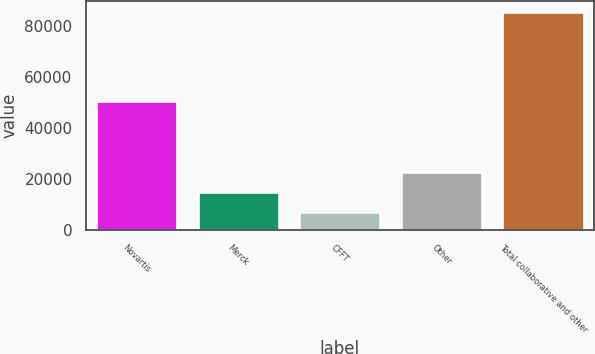Convert chart to OTSL. <chart><loc_0><loc_0><loc_500><loc_500><bar_chart><fcel>Novartis<fcel>Merck<fcel>CFFT<fcel>Other<fcel>Total collaborative and other<nl><fcel>50497<fcel>14652.3<fcel>6792<fcel>22512.6<fcel>85395<nl></chart> 